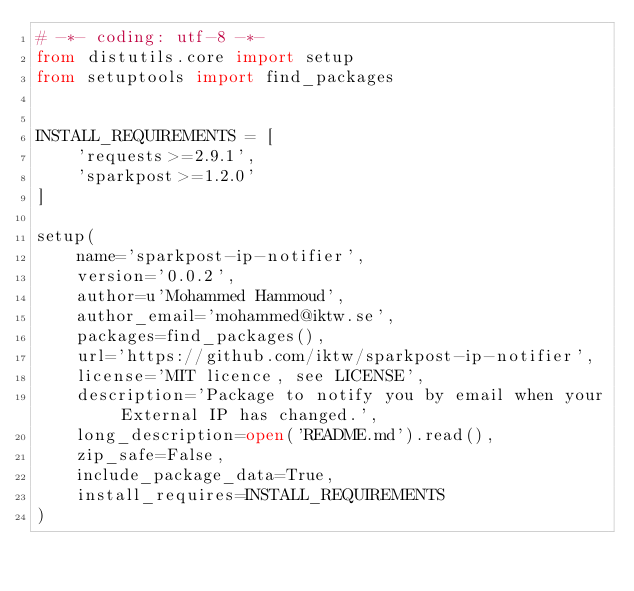<code> <loc_0><loc_0><loc_500><loc_500><_Python_># -*- coding: utf-8 -*-
from distutils.core import setup
from setuptools import find_packages


INSTALL_REQUIREMENTS = [
    'requests>=2.9.1',
    'sparkpost>=1.2.0'
]

setup(
    name='sparkpost-ip-notifier',
    version='0.0.2',
    author=u'Mohammed Hammoud',
    author_email='mohammed@iktw.se',
    packages=find_packages(),
    url='https://github.com/iktw/sparkpost-ip-notifier',
    license='MIT licence, see LICENSE',
    description='Package to notify you by email when your External IP has changed.',
    long_description=open('README.md').read(),
    zip_safe=False,
    include_package_data=True,
    install_requires=INSTALL_REQUIREMENTS
)
</code> 